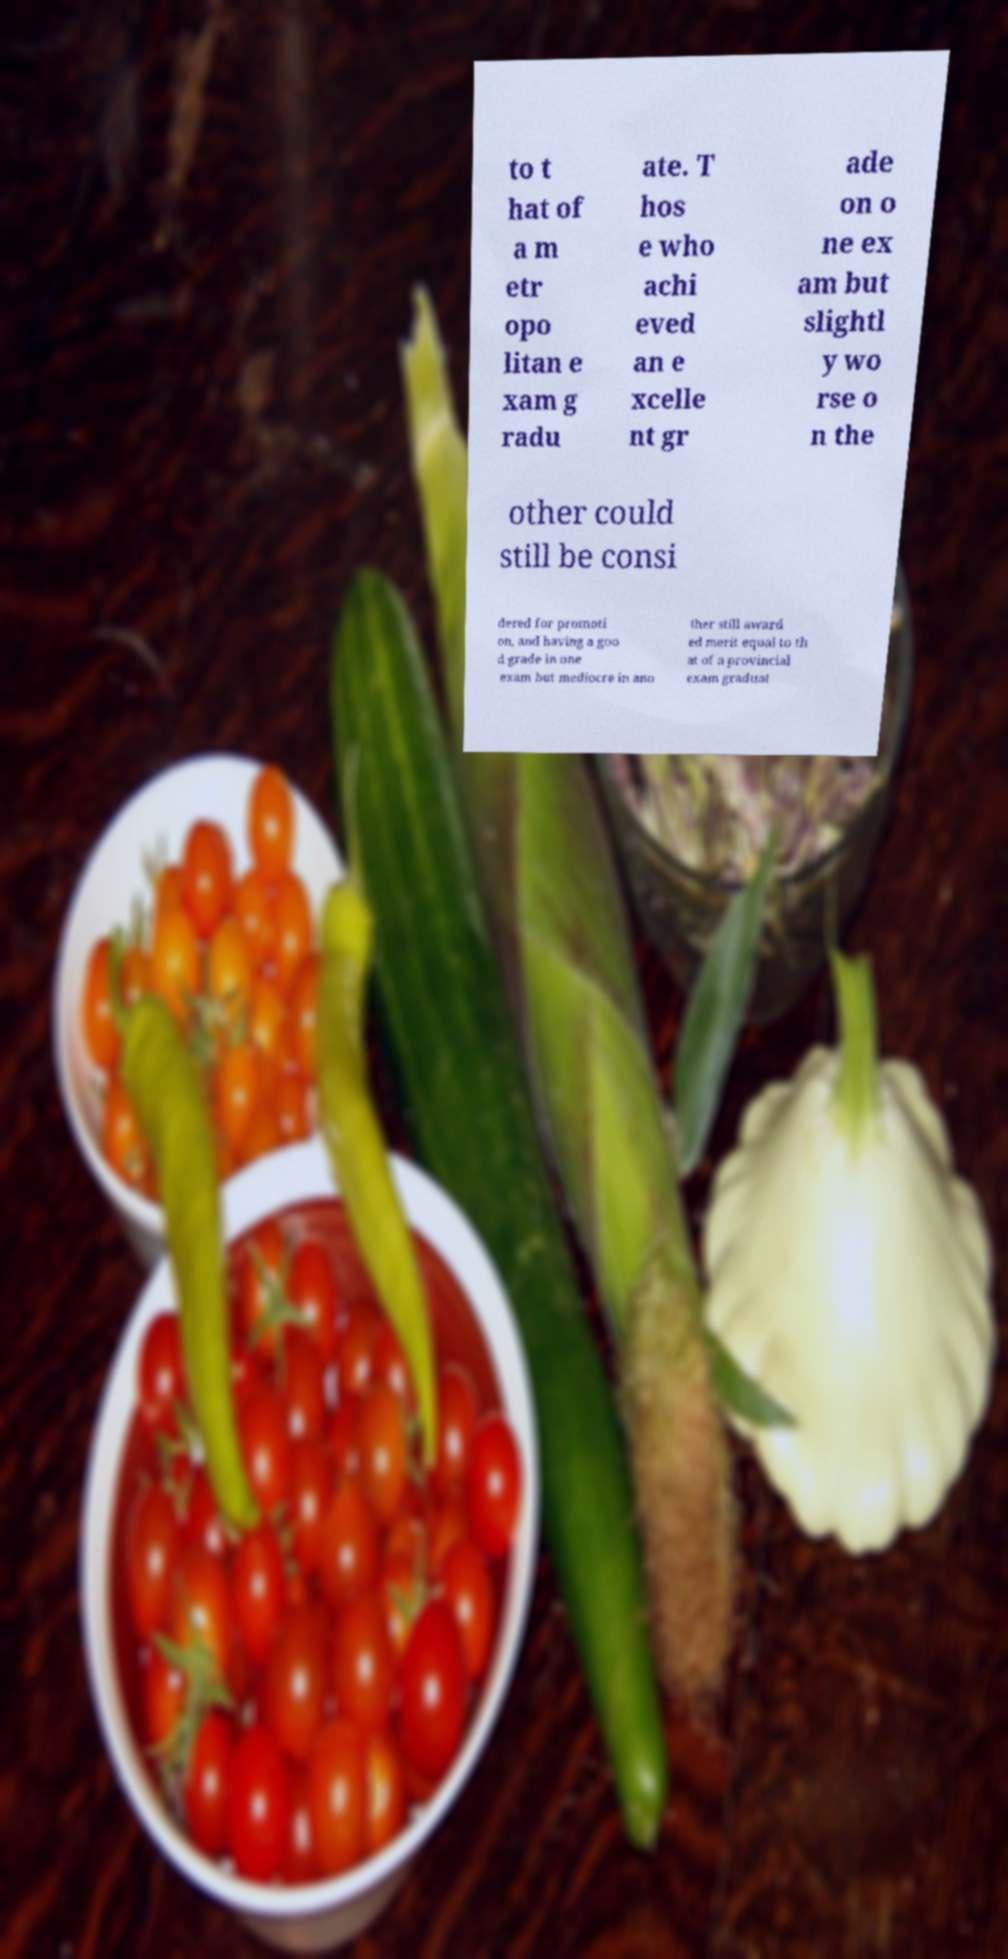Could you extract and type out the text from this image? to t hat of a m etr opo litan e xam g radu ate. T hos e who achi eved an e xcelle nt gr ade on o ne ex am but slightl y wo rse o n the other could still be consi dered for promoti on, and having a goo d grade in one exam but mediocre in ano ther still award ed merit equal to th at of a provincial exam graduat 